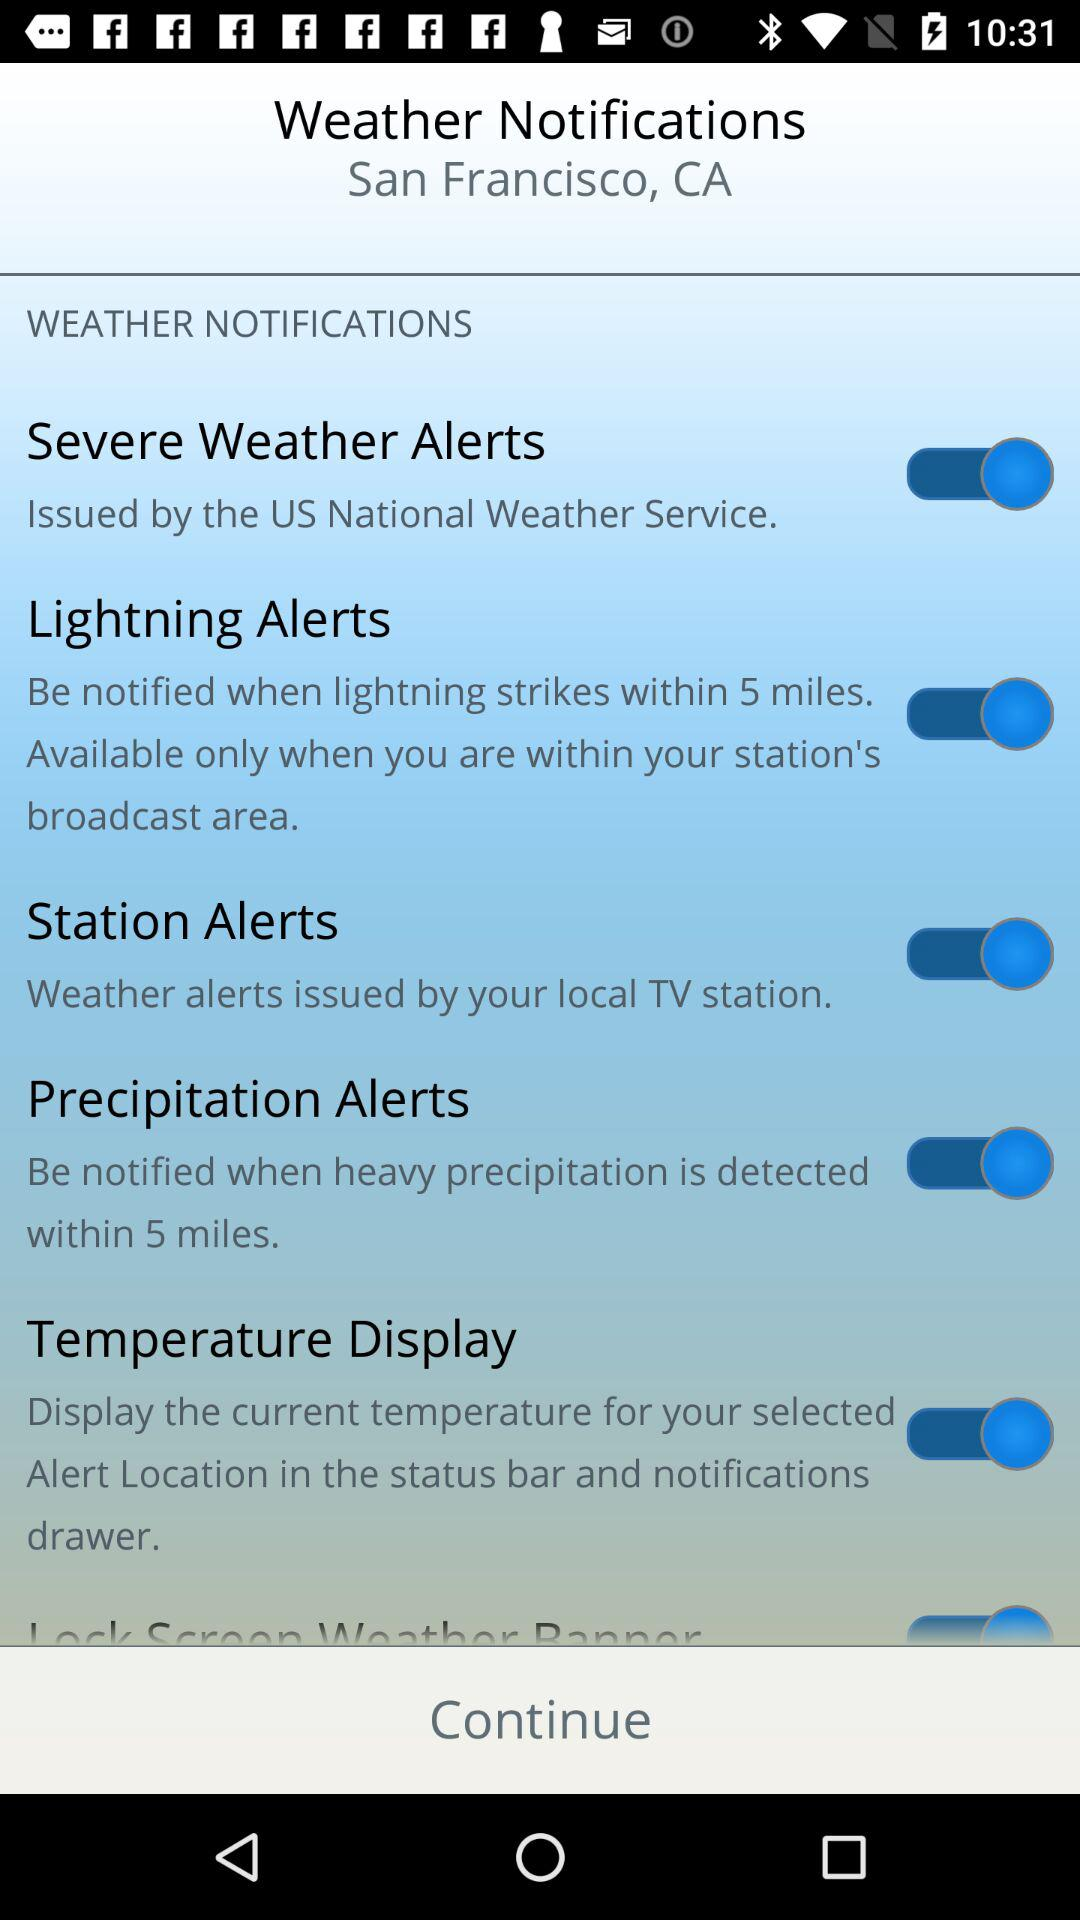What is the status of "Station Alerts"? The status is "on". 